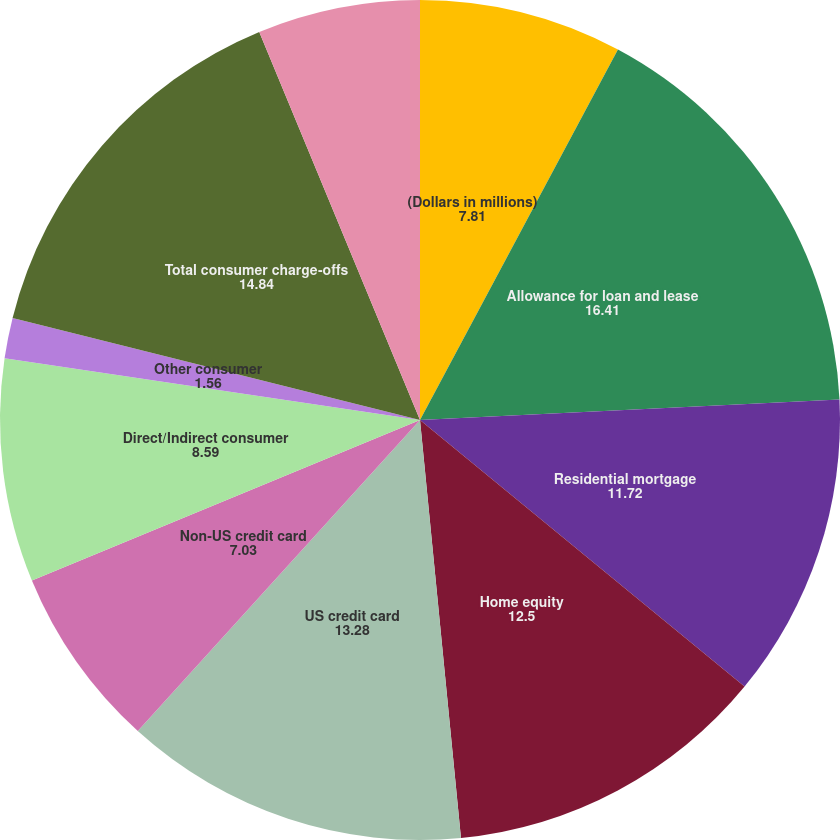Convert chart. <chart><loc_0><loc_0><loc_500><loc_500><pie_chart><fcel>(Dollars in millions)<fcel>Allowance for loan and lease<fcel>Residential mortgage<fcel>Home equity<fcel>US credit card<fcel>Non-US credit card<fcel>Direct/Indirect consumer<fcel>Other consumer<fcel>Total consumer charge-offs<fcel>US commercial (2)<nl><fcel>7.81%<fcel>16.41%<fcel>11.72%<fcel>12.5%<fcel>13.28%<fcel>7.03%<fcel>8.59%<fcel>1.56%<fcel>14.84%<fcel>6.25%<nl></chart> 